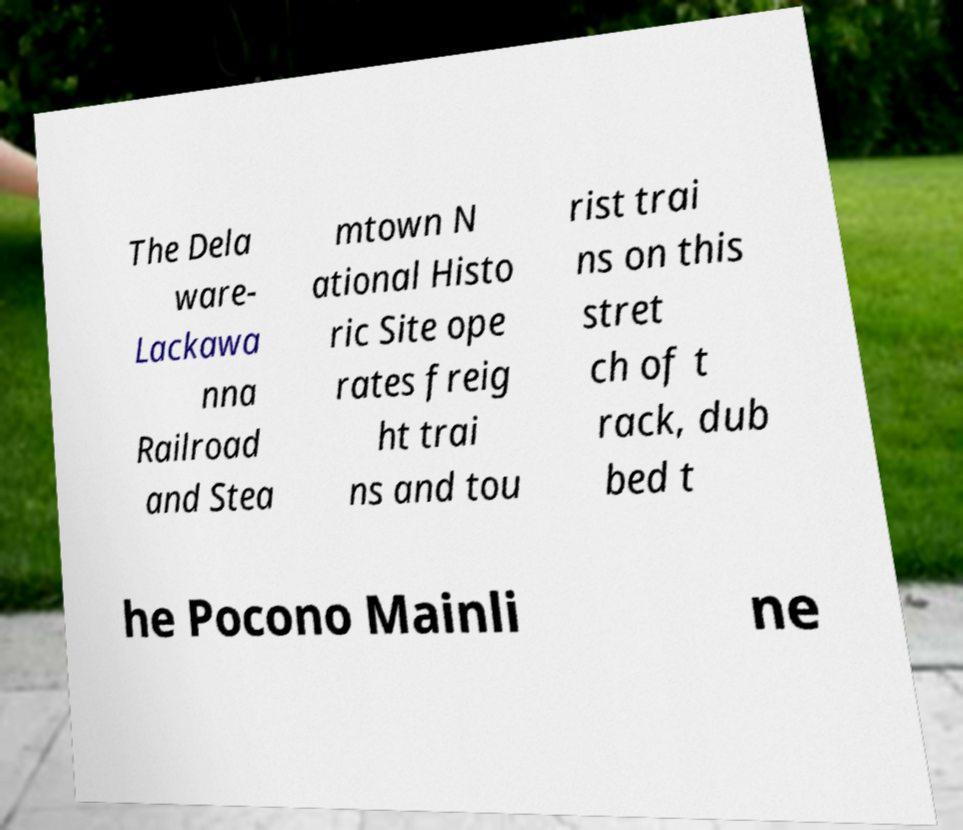For documentation purposes, I need the text within this image transcribed. Could you provide that? The Dela ware- Lackawa nna Railroad and Stea mtown N ational Histo ric Site ope rates freig ht trai ns and tou rist trai ns on this stret ch of t rack, dub bed t he Pocono Mainli ne 